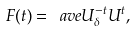Convert formula to latex. <formula><loc_0><loc_0><loc_500><loc_500>F ( t ) = \ a v e { U _ { \delta } ^ { - t } U ^ { t } } ,</formula> 